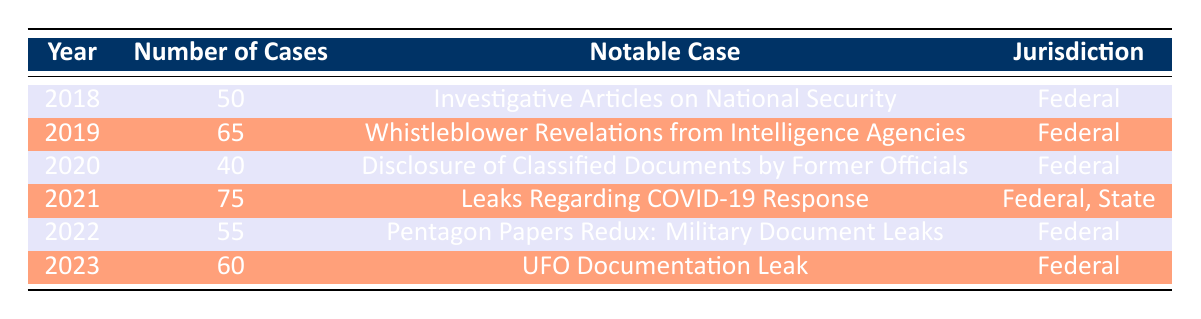What was the notable case in 2019? The notable case for the year 2019 is "Whistleblower Revelations from Intelligence Agencies," which is listed in the corresponding row of the table.
Answer: Whistleblower Revelations from Intelligence Agencies How many media leak cases were filed in 2021? In the year 2021, the number of media leak cases filed is 75, which is directly given in the table.
Answer: 75 What is the total number of media leak cases filed from 2018 to 2023? To find the total number of media leak cases from 2018 to 2023, we add the number of cases for each year: 50 + 65 + 40 + 75 + 55 + 60 = 345.
Answer: 345 Did the number of media leak cases increase from 2020 to 2021? Comparing the number of cases from 2020 (40 cases) to 2021 (75 cases), there is an increase since 75 is greater than 40.
Answer: Yes Which year had the highest number of cases, and what was that number? By examining the table, 2021 had the highest number of cases at 75. This can be confirmed by comparing the number of cases in each year.
Answer: 2021: 75 Is there a year in which the number of cases was above 60? The years 2019 (65), 2021 (75), and 2023 (60) all have case numbers greater than 60, thus the answer is yes.
Answer: Yes What is the average number of media leak cases filed per year from 2018 to 2023? To find the average, we first calculate the total number of cases (which is 345 as previously calculated) and divide it by the number of years, which is 6. Therefore, the average is 345 / 6 = 57.5.
Answer: 57.5 In which years did the Federal jurisdiction handle the most cases? By checking the rows for years with Federal jurisdiction, 2019 had 65 cases, and 2021 had 75 cases, so these years had the most cases for Federal jurisdiction.
Answer: 2019, 2021 Was there a notable case in 2022, and if so, what was it? The table indicates that in 2022, the notable case was "Pentagon Papers Redux: Military Document Leaks," confirming that there was indeed a notable case that year.
Answer: Pentagon Papers Redux: Military Document Leaks 